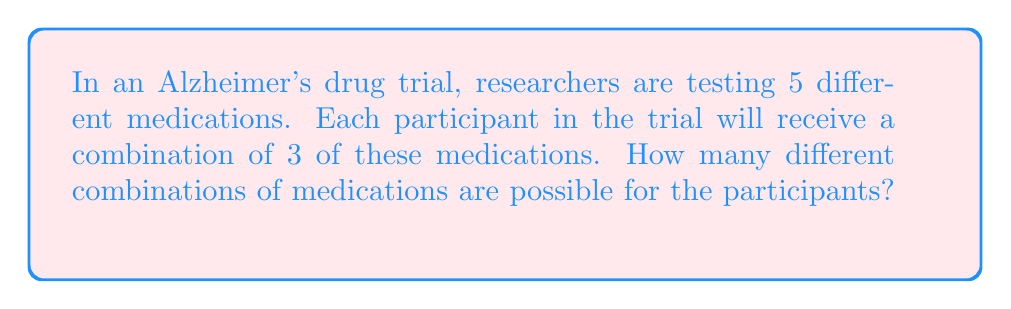Provide a solution to this math problem. Let's approach this step-by-step:

1) This is a combination problem. We are selecting 3 medications out of 5, where the order doesn't matter (it's not important which medication is given first, second, or third).

2) The formula for combinations is:

   $$C(n,r) = \frac{n!}{r!(n-r)!}$$

   Where $n$ is the total number of items to choose from, and $r$ is the number of items being chosen.

3) In this case, $n = 5$ (total medications) and $r = 3$ (medications given to each participant).

4) Let's substitute these values into our formula:

   $$C(5,3) = \frac{5!}{3!(5-3)!} = \frac{5!}{3!2!}$$

5) Expand this:
   $$\frac{5 \times 4 \times 3!}{3! \times 2 \times 1}$$

6) The 3! cancels out in the numerator and denominator:

   $$\frac{5 \times 4}{2 \times 1} = \frac{20}{2} = 10$$

Therefore, there are 10 possible combinations of medications that can be given to participants in this Alzheimer's drug trial.
Answer: 10 combinations 